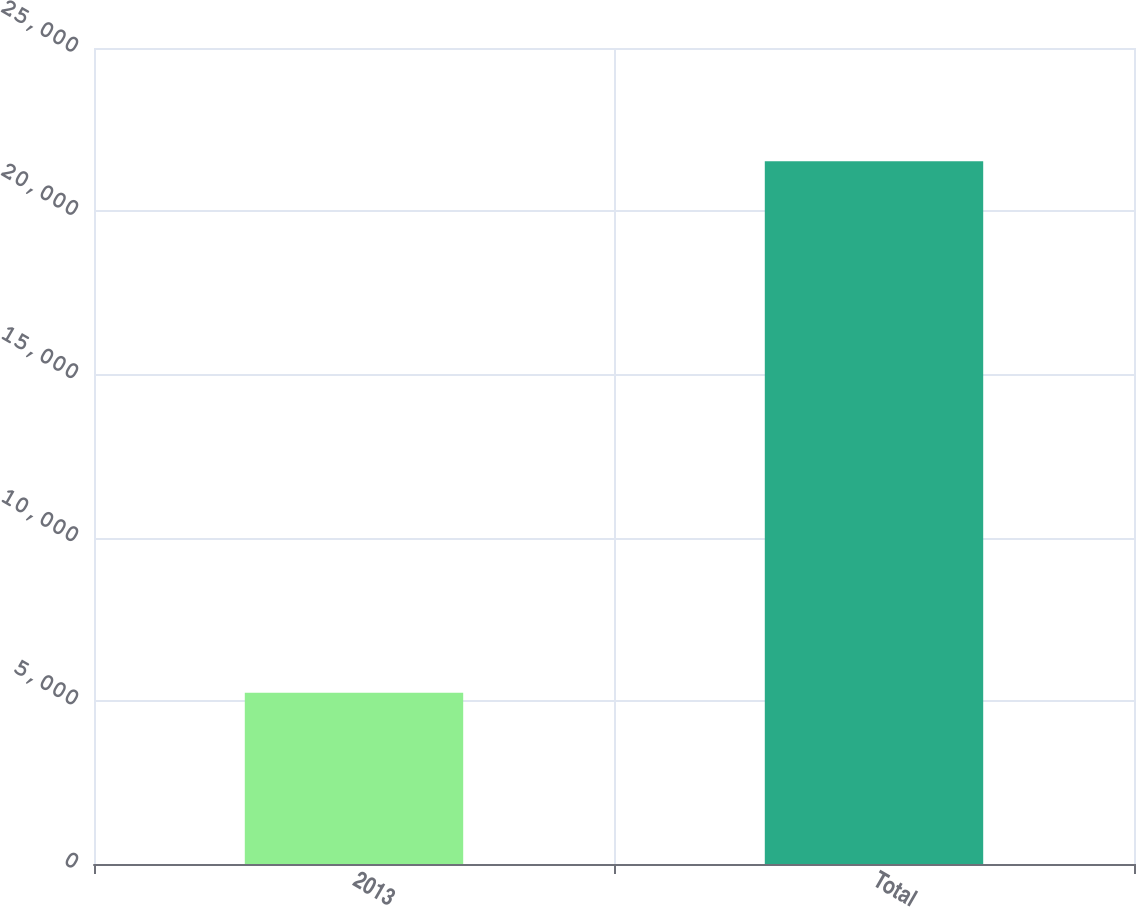Convert chart. <chart><loc_0><loc_0><loc_500><loc_500><bar_chart><fcel>2013<fcel>Total<nl><fcel>5248<fcel>21532<nl></chart> 